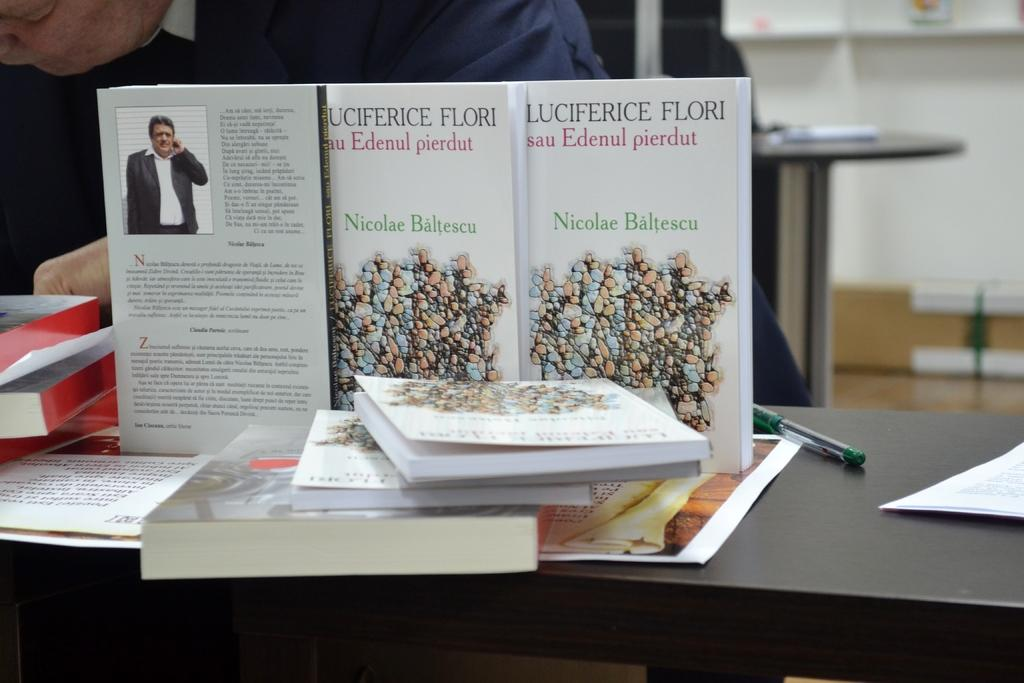<image>
Summarize the visual content of the image. The book "Luciferice Flori" is lined up on a table in front of the author. 